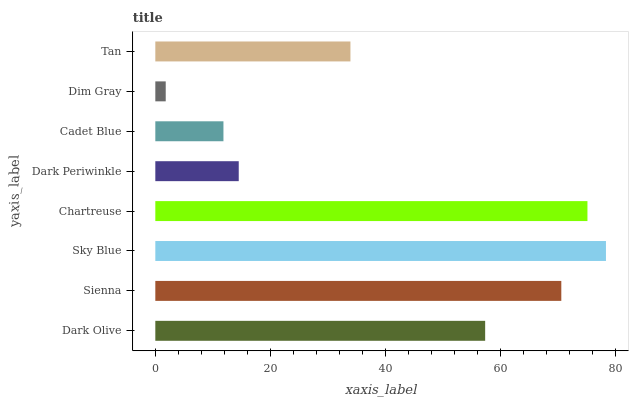Is Dim Gray the minimum?
Answer yes or no. Yes. Is Sky Blue the maximum?
Answer yes or no. Yes. Is Sienna the minimum?
Answer yes or no. No. Is Sienna the maximum?
Answer yes or no. No. Is Sienna greater than Dark Olive?
Answer yes or no. Yes. Is Dark Olive less than Sienna?
Answer yes or no. Yes. Is Dark Olive greater than Sienna?
Answer yes or no. No. Is Sienna less than Dark Olive?
Answer yes or no. No. Is Dark Olive the high median?
Answer yes or no. Yes. Is Tan the low median?
Answer yes or no. Yes. Is Sky Blue the high median?
Answer yes or no. No. Is Dark Periwinkle the low median?
Answer yes or no. No. 